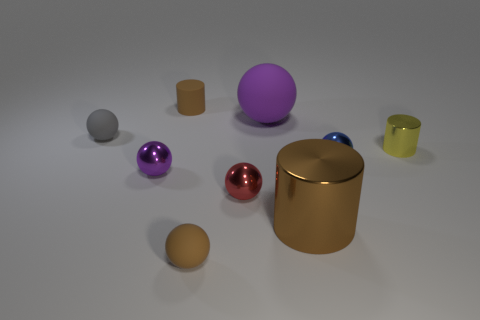Is there a tiny yellow metallic cylinder?
Make the answer very short. Yes. There is a matte ball in front of the tiny gray sphere; what is its color?
Your answer should be very brief. Brown. Do the brown shiny thing and the brown rubber object in front of the red object have the same size?
Your answer should be compact. No. How big is the thing that is in front of the tiny red thing and right of the purple rubber thing?
Offer a very short reply. Large. Are there any large brown things made of the same material as the tiny yellow thing?
Offer a very short reply. Yes. There is a gray rubber thing; what shape is it?
Ensure brevity in your answer.  Sphere. Do the red metal thing and the brown metallic object have the same size?
Ensure brevity in your answer.  No. What number of other things are there of the same shape as the big rubber thing?
Give a very brief answer. 5. There is a shiny object that is on the left side of the rubber cylinder; what is its shape?
Provide a short and direct response. Sphere. Do the brown object behind the small yellow metallic cylinder and the small thing that is in front of the large cylinder have the same shape?
Keep it short and to the point. No. 